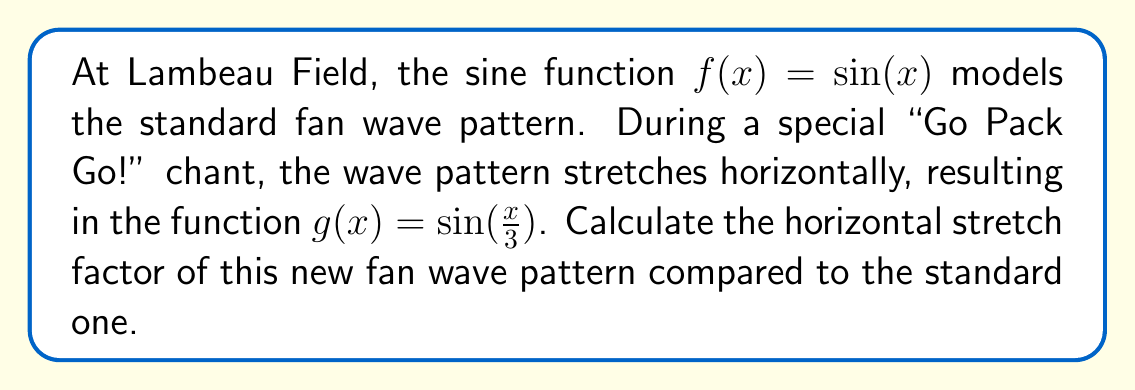Solve this math problem. To determine the horizontal stretch factor, we need to compare the general forms of the original function $f(x)$ and the new function $g(x)$.

1) The standard form of a horizontally stretched sine function is:

   $$y = \sin(\frac{x}{k})$$

   where $k$ is the stretch factor.

2) In our case:
   
   $f(x) = \sin(x)$ (original function)
   $g(x) = \sin(\frac{x}{3})$ (stretched function)

3) Comparing $g(x)$ to the standard form, we can see that $k = 3$.

4) The stretch factor $k$ represents how many times wider the new graph is compared to the original. A factor of 3 means the new wave pattern is stretched to be 3 times wider than the original.

5) We can verify this by considering key points:
   - In $f(x)$, a full cycle occurs over an interval of $2\pi$.
   - In $g(x)$, a full cycle occurs over an interval of $6\pi$, which is 3 times wider.

Therefore, the horizontal stretch factor is 3.
Answer: The horizontal stretch factor is 3. 